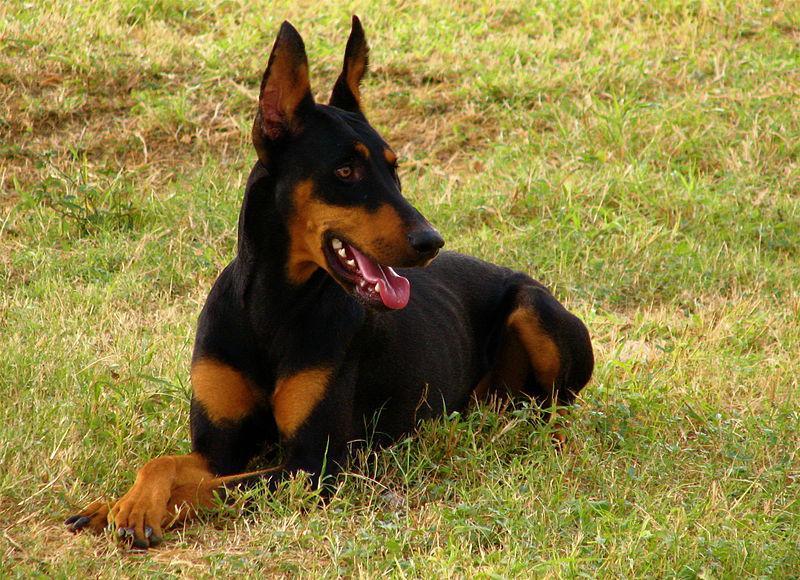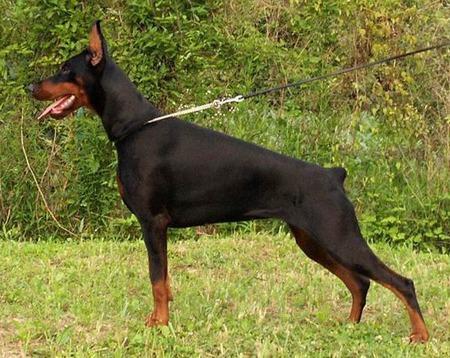The first image is the image on the left, the second image is the image on the right. Considering the images on both sides, is "The combined images contain exactly two reclining dobermans with upright ears and faces angled forward so both eyes are visible." valid? Answer yes or no. No. The first image is the image on the left, the second image is the image on the right. Given the left and right images, does the statement "There are at least three dogs in total." hold true? Answer yes or no. No. 